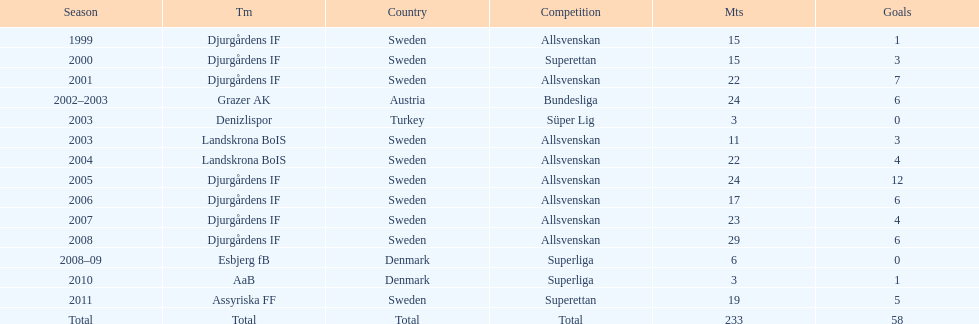How many total goals has jones kusi-asare scored? 58. 